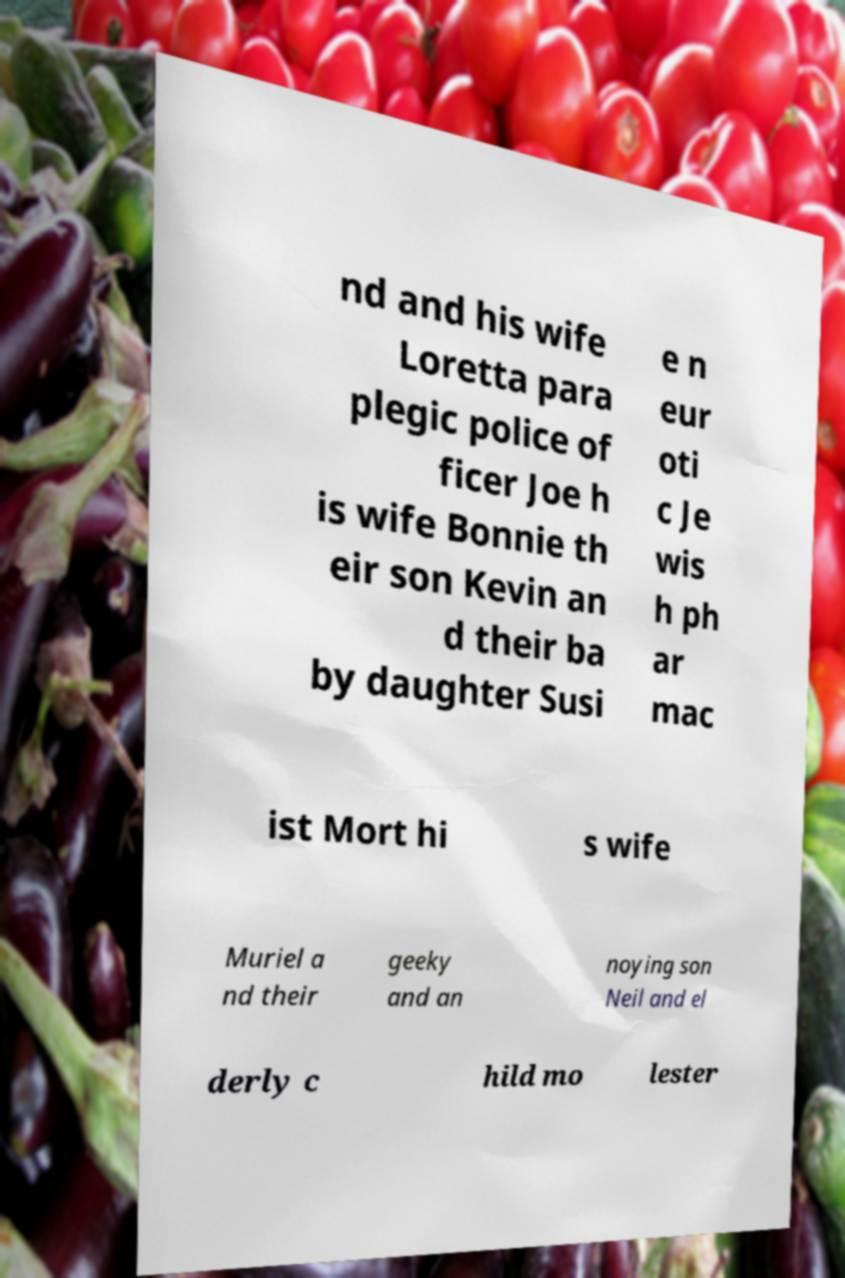Could you extract and type out the text from this image? nd and his wife Loretta para plegic police of ficer Joe h is wife Bonnie th eir son Kevin an d their ba by daughter Susi e n eur oti c Je wis h ph ar mac ist Mort hi s wife Muriel a nd their geeky and an noying son Neil and el derly c hild mo lester 